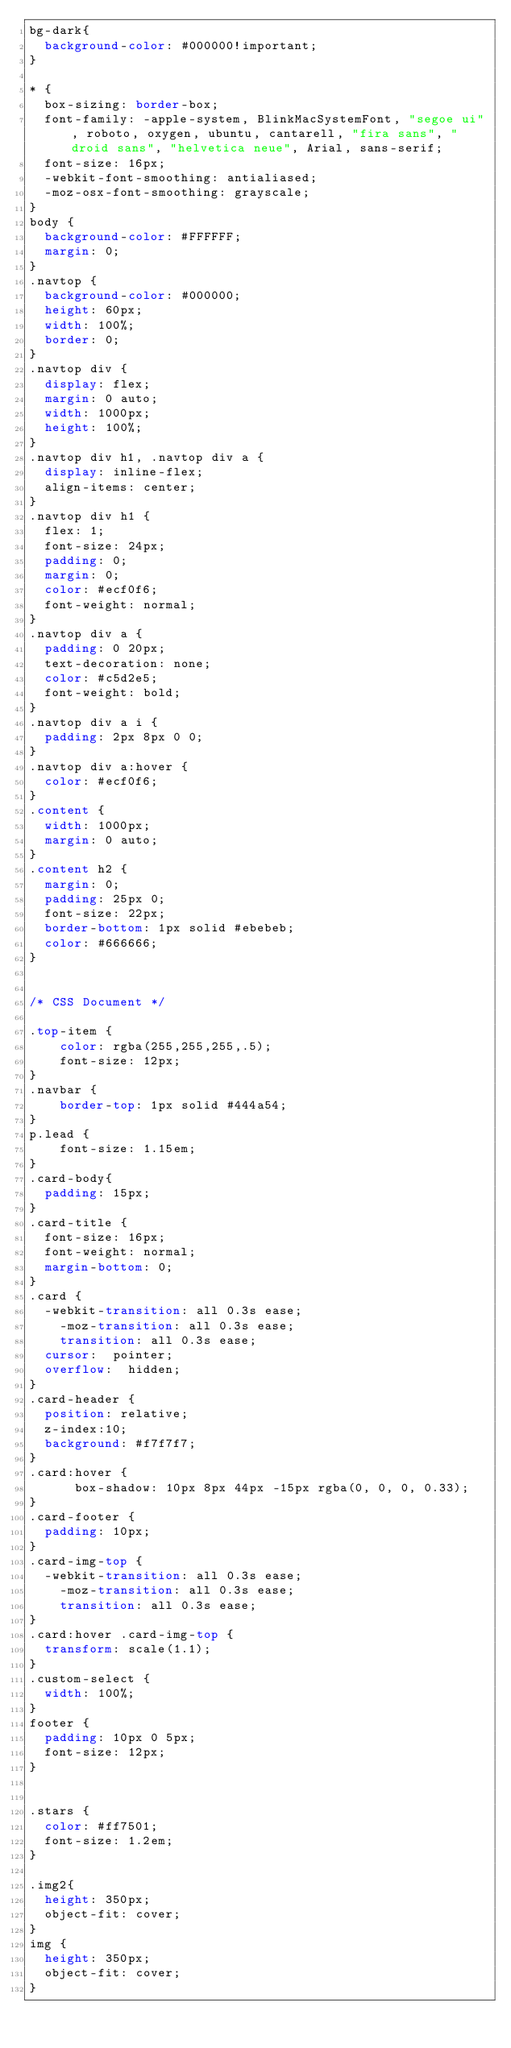<code> <loc_0><loc_0><loc_500><loc_500><_CSS_>bg-dark{
  background-color: #000000!important;
}

* {
  box-sizing: border-box;
  font-family: -apple-system, BlinkMacSystemFont, "segoe ui", roboto, oxygen, ubuntu, cantarell, "fira sans", "droid sans", "helvetica neue", Arial, sans-serif;
  font-size: 16px;
  -webkit-font-smoothing: antialiased;
  -moz-osx-font-smoothing: grayscale;
}
body {
  background-color: #FFFFFF;
  margin: 0;
}
.navtop {
  background-color: #000000;
  height: 60px;
  width: 100%;
  border: 0;
}
.navtop div {
  display: flex;
  margin: 0 auto;
  width: 1000px;
  height: 100%;
}
.navtop div h1, .navtop div a {
  display: inline-flex;
  align-items: center;
}
.navtop div h1 {
  flex: 1;
  font-size: 24px;
  padding: 0;
  margin: 0;
  color: #ecf0f6;
  font-weight: normal;
}
.navtop div a {
  padding: 0 20px;
  text-decoration: none;
  color: #c5d2e5;
  font-weight: bold;
}
.navtop div a i {
  padding: 2px 8px 0 0;
}
.navtop div a:hover {
  color: #ecf0f6;
}
.content {
  width: 1000px;
  margin: 0 auto;
}
.content h2 {
  margin: 0;
  padding: 25px 0;
  font-size: 22px;
  border-bottom: 1px solid #ebebeb;
  color: #666666;
}


/* CSS Document */

.top-item {
	color: rgba(255,255,255,.5);
	font-size: 12px;
}
.navbar {
	border-top: 1px solid #444a54;
}
p.lead {
	font-size: 1.15em;
}
.card-body{
  padding: 15px;
}
.card-title {
  font-size: 16px;
  font-weight: normal;
  margin-bottom: 0;
}
.card {
  -webkit-transition: all 0.3s ease;
    -moz-transition: all 0.3s ease;
    transition: all 0.3s ease;
  cursor:  pointer;
  overflow:  hidden;
}
.card-header {
  position: relative;
  z-index:10;
  background: #f7f7f7;
}
.card:hover {
      box-shadow: 10px 8px 44px -15px rgba(0, 0, 0, 0.33);
}
.card-footer {
  padding: 10px;
}
.card-img-top {
  -webkit-transition: all 0.3s ease;
    -moz-transition: all 0.3s ease;
    transition: all 0.3s ease;
}
.card:hover .card-img-top {
  transform: scale(1.1);
}
.custom-select {
  width: 100%;
}
footer {
  padding: 10px 0 5px;
  font-size: 12px;
}


.stars {
  color: #ff7501;
  font-size: 1.2em;
}

.img2{
  height: 350px;
  object-fit: cover;
}
img {
  height: 350px;
  object-fit: cover;
}</code> 